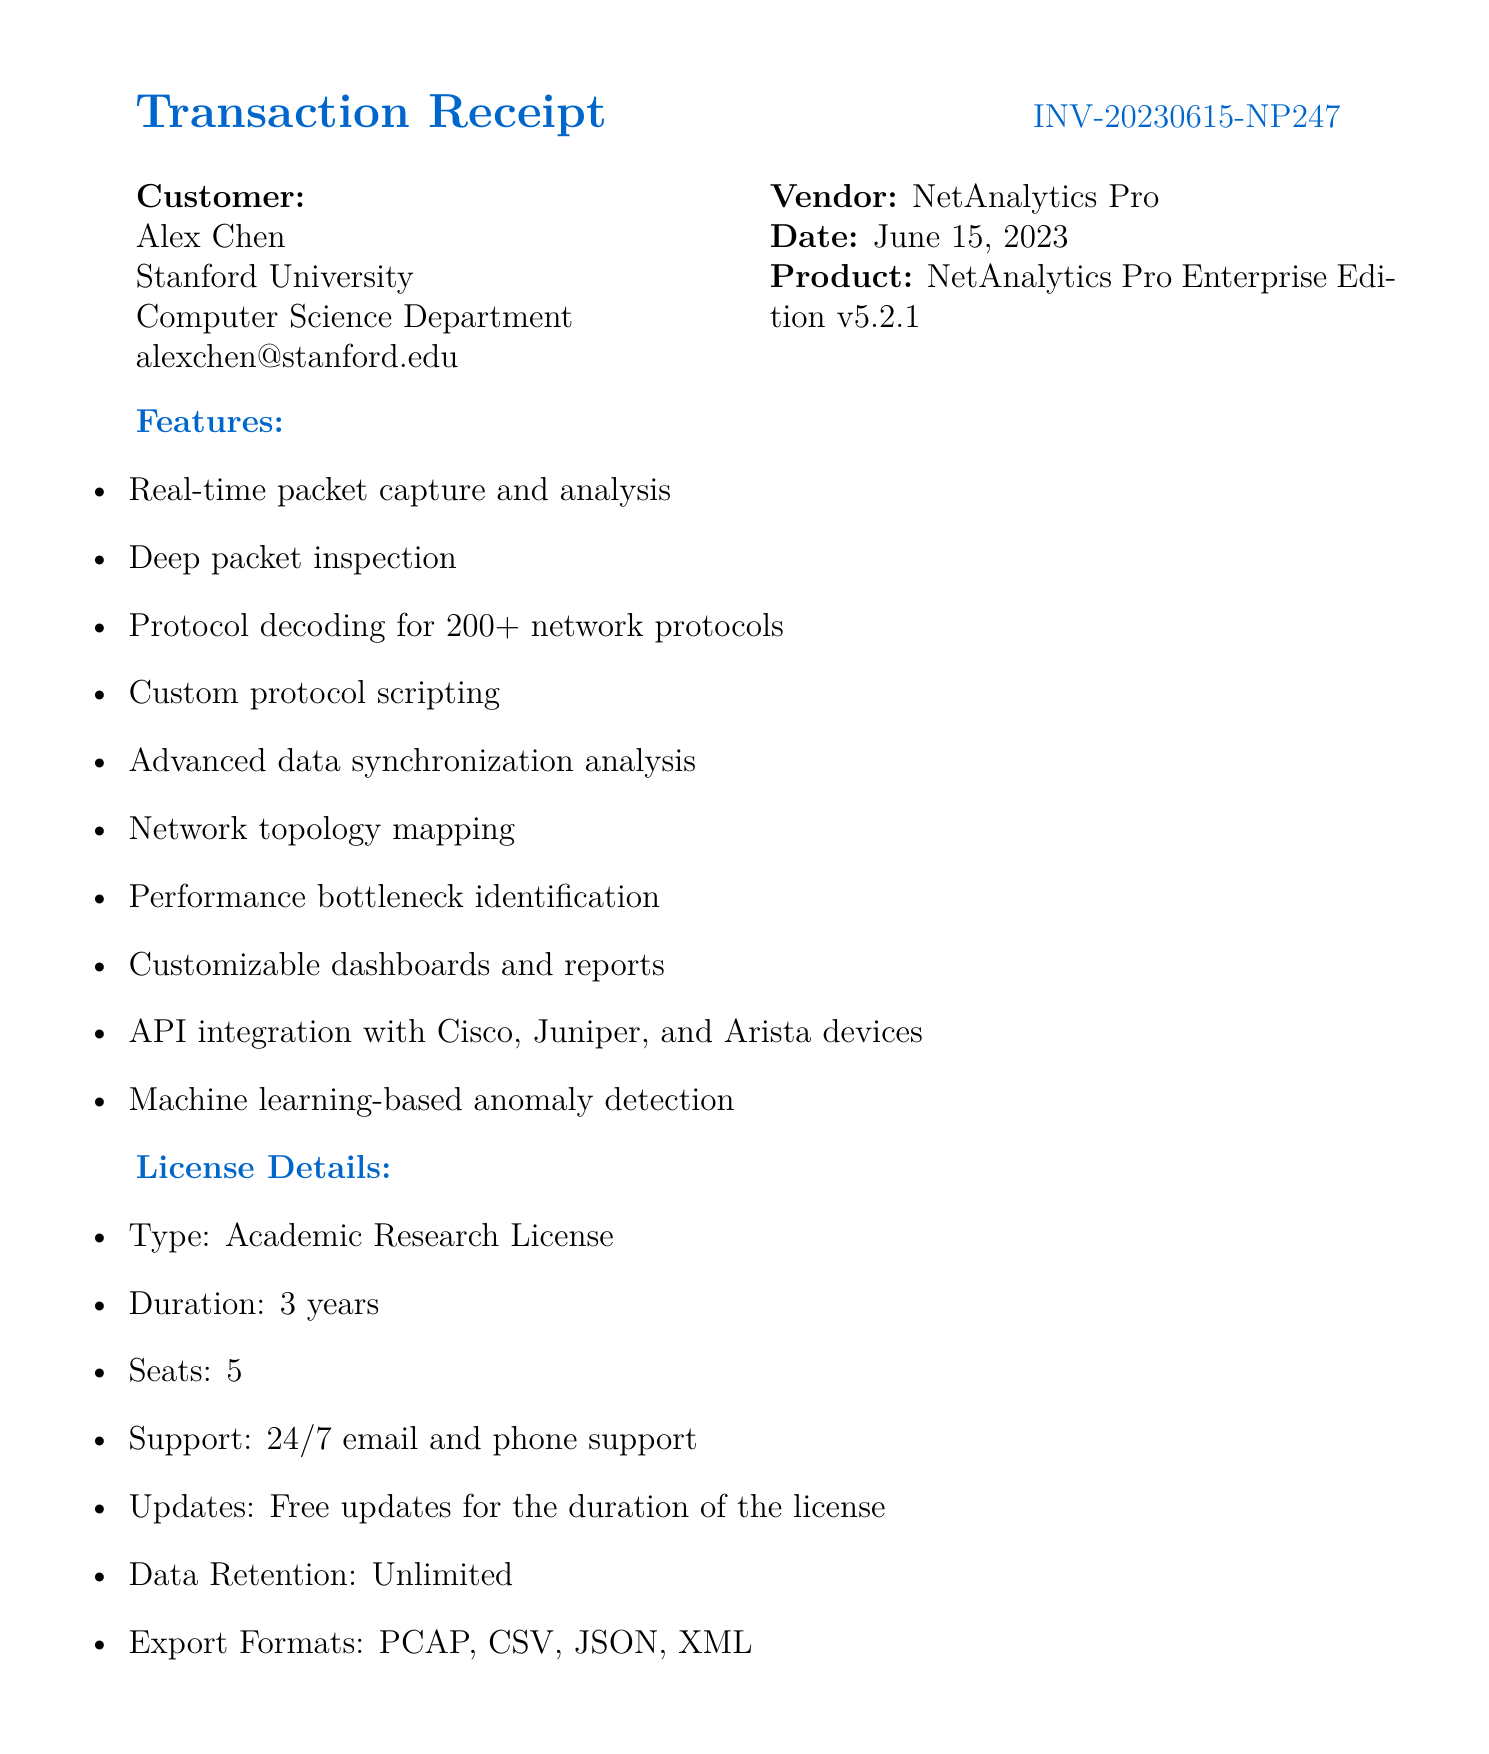What is the receipt number? The receipt number is found in the document heading, labeled as such.
Answer: INV-20230615-NP247 What is the date of the transaction? The date is specified right next to the receipt number in the document.
Answer: June 15, 2023 Who is the customer? The customer's name is listed in the customer details section of the document.
Answer: Alex Chen How many seats are included in the license? This information is provided in the license details section of the document.
Answer: 5 What is the total price of the software? The total price is mentioned at the end of the pricing section.
Answer: 5,231.97 What type of license is provided? The license type is clearly stated in the license details section of the document.
Answer: Academic Research License What is included with the license in terms of support? Support details are part of the license information described in the document.
Answer: 24/7 email and phone support How long is the license valid? The duration of the license is mentioned in the license details.
Answer: 3 years What discount was applied to the base price? The academic discount is specified in the pricing table of the document.
Answer: -1,000.00 What additional training is offered? Additional notes at the end of the document mention this information.
Answer: Complimentary 2-day online training session for up to 10 users 